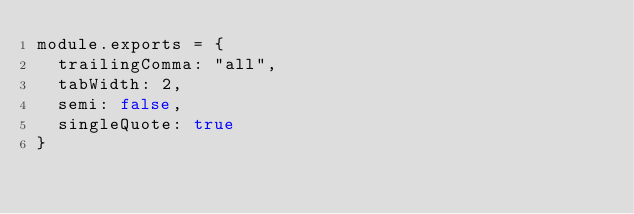Convert code to text. <code><loc_0><loc_0><loc_500><loc_500><_JavaScript_>module.exports = {
  trailingComma: "all",
  tabWidth: 2,
  semi: false,
  singleQuote: true
}</code> 